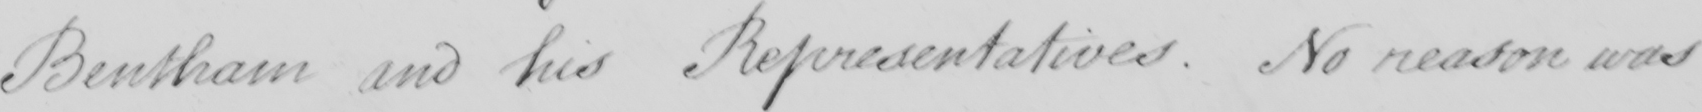Can you read and transcribe this handwriting? Bentham and his Representatives. No reason was 